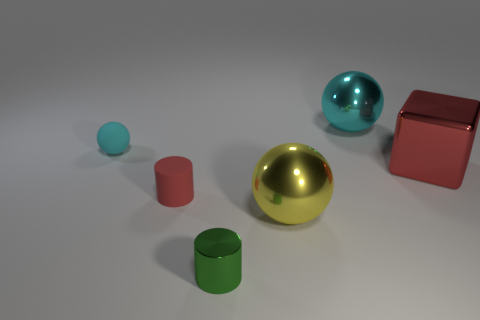Add 3 small purple metal spheres. How many objects exist? 9 Subtract all cubes. How many objects are left? 5 Add 4 tiny green shiny cylinders. How many tiny green shiny cylinders exist? 5 Subtract 0 yellow cubes. How many objects are left? 6 Subtract all small balls. Subtract all red metallic objects. How many objects are left? 4 Add 4 rubber balls. How many rubber balls are left? 5 